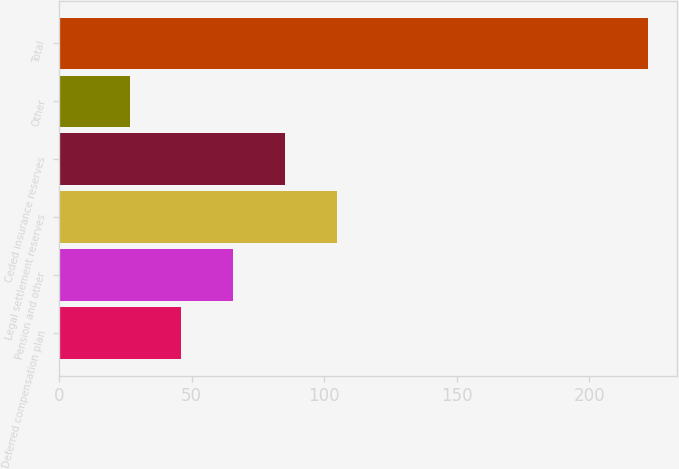Convert chart. <chart><loc_0><loc_0><loc_500><loc_500><bar_chart><fcel>Deferred compensation plan<fcel>Pension and other<fcel>Legal settlement reserves<fcel>Ceded insurance reserves<fcel>Other<fcel>Total<nl><fcel>46.15<fcel>65.7<fcel>104.8<fcel>85.25<fcel>26.6<fcel>222.1<nl></chart> 